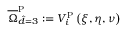<formula> <loc_0><loc_0><loc_500><loc_500>\overline { \Omega } _ { \hat { d } = 3 } ^ { P } \colon = V _ { i } ^ { P } \left ( \xi , \eta , \nu \right )</formula> 